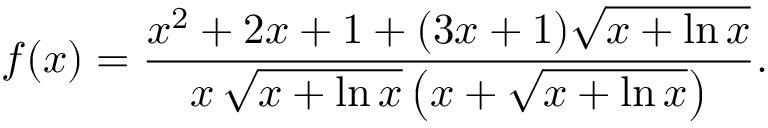Convert formula to latex. <formula><loc_0><loc_0><loc_500><loc_500>f ( x ) = { \frac { x ^ { 2 } + 2 x + 1 + ( 3 x + 1 ) { \sqrt { x + \ln x } } } { x \, { \sqrt { x + \ln x } } \left ( x + { \sqrt { x + \ln x } } \right ) } } .</formula> 